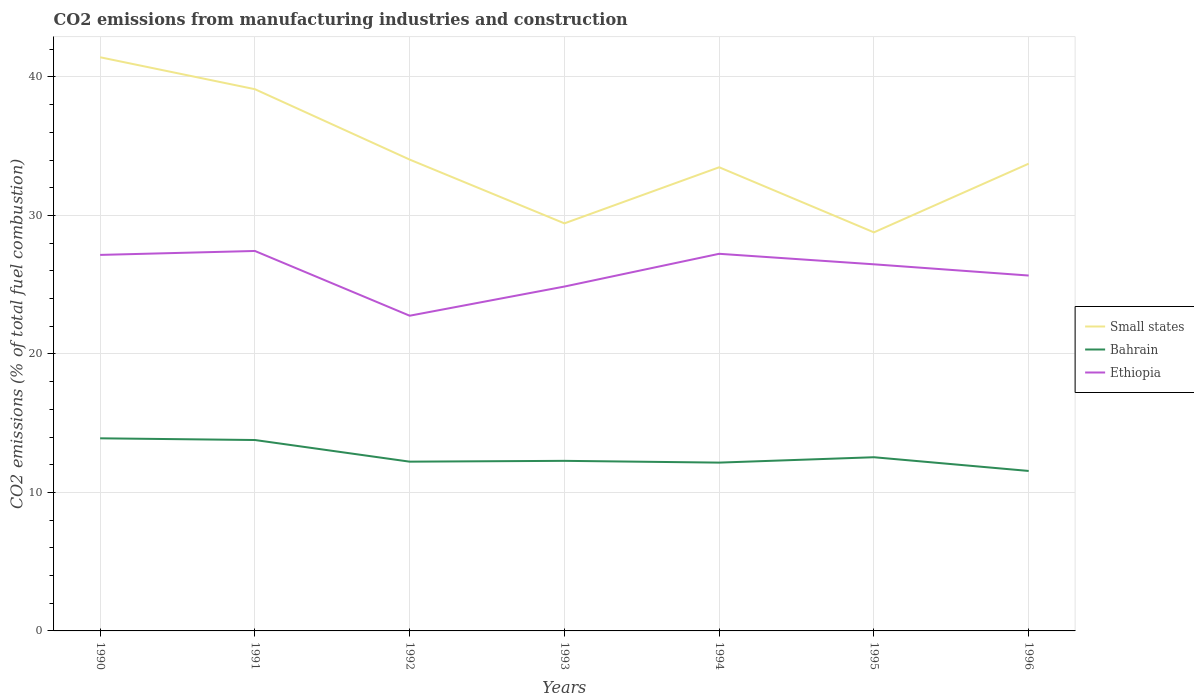Across all years, what is the maximum amount of CO2 emitted in Small states?
Ensure brevity in your answer.  28.78. What is the total amount of CO2 emitted in Bahrain in the graph?
Give a very brief answer. -0.39. What is the difference between the highest and the second highest amount of CO2 emitted in Small states?
Keep it short and to the point. 12.64. How many lines are there?
Your answer should be compact. 3. How many years are there in the graph?
Offer a very short reply. 7. Does the graph contain any zero values?
Provide a succinct answer. No. Does the graph contain grids?
Your answer should be compact. Yes. Where does the legend appear in the graph?
Your response must be concise. Center right. How are the legend labels stacked?
Provide a succinct answer. Vertical. What is the title of the graph?
Ensure brevity in your answer.  CO2 emissions from manufacturing industries and construction. Does "Spain" appear as one of the legend labels in the graph?
Offer a very short reply. No. What is the label or title of the Y-axis?
Keep it short and to the point. CO2 emissions (% of total fuel combustion). What is the CO2 emissions (% of total fuel combustion) of Small states in 1990?
Provide a succinct answer. 41.42. What is the CO2 emissions (% of total fuel combustion) in Bahrain in 1990?
Your answer should be compact. 13.91. What is the CO2 emissions (% of total fuel combustion) in Ethiopia in 1990?
Provide a short and direct response. 27.15. What is the CO2 emissions (% of total fuel combustion) of Small states in 1991?
Your answer should be compact. 39.11. What is the CO2 emissions (% of total fuel combustion) of Bahrain in 1991?
Offer a terse response. 13.78. What is the CO2 emissions (% of total fuel combustion) of Ethiopia in 1991?
Your response must be concise. 27.43. What is the CO2 emissions (% of total fuel combustion) of Small states in 1992?
Your response must be concise. 34.03. What is the CO2 emissions (% of total fuel combustion) in Bahrain in 1992?
Your answer should be very brief. 12.22. What is the CO2 emissions (% of total fuel combustion) of Ethiopia in 1992?
Provide a short and direct response. 22.76. What is the CO2 emissions (% of total fuel combustion) of Small states in 1993?
Keep it short and to the point. 29.43. What is the CO2 emissions (% of total fuel combustion) in Bahrain in 1993?
Ensure brevity in your answer.  12.28. What is the CO2 emissions (% of total fuel combustion) in Ethiopia in 1993?
Your answer should be compact. 24.86. What is the CO2 emissions (% of total fuel combustion) in Small states in 1994?
Make the answer very short. 33.48. What is the CO2 emissions (% of total fuel combustion) of Bahrain in 1994?
Provide a short and direct response. 12.15. What is the CO2 emissions (% of total fuel combustion) of Ethiopia in 1994?
Offer a very short reply. 27.23. What is the CO2 emissions (% of total fuel combustion) in Small states in 1995?
Your response must be concise. 28.78. What is the CO2 emissions (% of total fuel combustion) of Bahrain in 1995?
Offer a terse response. 12.54. What is the CO2 emissions (% of total fuel combustion) of Ethiopia in 1995?
Your answer should be compact. 26.47. What is the CO2 emissions (% of total fuel combustion) of Small states in 1996?
Provide a succinct answer. 33.74. What is the CO2 emissions (% of total fuel combustion) of Bahrain in 1996?
Your answer should be very brief. 11.55. What is the CO2 emissions (% of total fuel combustion) of Ethiopia in 1996?
Provide a succinct answer. 25.66. Across all years, what is the maximum CO2 emissions (% of total fuel combustion) in Small states?
Provide a short and direct response. 41.42. Across all years, what is the maximum CO2 emissions (% of total fuel combustion) in Bahrain?
Make the answer very short. 13.91. Across all years, what is the maximum CO2 emissions (% of total fuel combustion) in Ethiopia?
Ensure brevity in your answer.  27.43. Across all years, what is the minimum CO2 emissions (% of total fuel combustion) in Small states?
Give a very brief answer. 28.78. Across all years, what is the minimum CO2 emissions (% of total fuel combustion) of Bahrain?
Offer a very short reply. 11.55. Across all years, what is the minimum CO2 emissions (% of total fuel combustion) of Ethiopia?
Your answer should be compact. 22.76. What is the total CO2 emissions (% of total fuel combustion) in Small states in the graph?
Provide a succinct answer. 239.99. What is the total CO2 emissions (% of total fuel combustion) of Bahrain in the graph?
Your answer should be compact. 88.44. What is the total CO2 emissions (% of total fuel combustion) in Ethiopia in the graph?
Your response must be concise. 181.57. What is the difference between the CO2 emissions (% of total fuel combustion) in Small states in 1990 and that in 1991?
Your response must be concise. 2.31. What is the difference between the CO2 emissions (% of total fuel combustion) of Bahrain in 1990 and that in 1991?
Ensure brevity in your answer.  0.12. What is the difference between the CO2 emissions (% of total fuel combustion) of Ethiopia in 1990 and that in 1991?
Offer a very short reply. -0.28. What is the difference between the CO2 emissions (% of total fuel combustion) in Small states in 1990 and that in 1992?
Offer a terse response. 7.39. What is the difference between the CO2 emissions (% of total fuel combustion) of Bahrain in 1990 and that in 1992?
Provide a short and direct response. 1.69. What is the difference between the CO2 emissions (% of total fuel combustion) in Ethiopia in 1990 and that in 1992?
Ensure brevity in your answer.  4.39. What is the difference between the CO2 emissions (% of total fuel combustion) in Small states in 1990 and that in 1993?
Give a very brief answer. 11.99. What is the difference between the CO2 emissions (% of total fuel combustion) of Bahrain in 1990 and that in 1993?
Provide a succinct answer. 1.63. What is the difference between the CO2 emissions (% of total fuel combustion) in Ethiopia in 1990 and that in 1993?
Give a very brief answer. 2.28. What is the difference between the CO2 emissions (% of total fuel combustion) of Small states in 1990 and that in 1994?
Keep it short and to the point. 7.94. What is the difference between the CO2 emissions (% of total fuel combustion) of Bahrain in 1990 and that in 1994?
Make the answer very short. 1.75. What is the difference between the CO2 emissions (% of total fuel combustion) of Ethiopia in 1990 and that in 1994?
Your answer should be very brief. -0.08. What is the difference between the CO2 emissions (% of total fuel combustion) in Small states in 1990 and that in 1995?
Keep it short and to the point. 12.64. What is the difference between the CO2 emissions (% of total fuel combustion) in Bahrain in 1990 and that in 1995?
Your answer should be compact. 1.37. What is the difference between the CO2 emissions (% of total fuel combustion) of Ethiopia in 1990 and that in 1995?
Your answer should be very brief. 0.68. What is the difference between the CO2 emissions (% of total fuel combustion) in Small states in 1990 and that in 1996?
Make the answer very short. 7.68. What is the difference between the CO2 emissions (% of total fuel combustion) in Bahrain in 1990 and that in 1996?
Offer a terse response. 2.36. What is the difference between the CO2 emissions (% of total fuel combustion) of Ethiopia in 1990 and that in 1996?
Give a very brief answer. 1.49. What is the difference between the CO2 emissions (% of total fuel combustion) of Small states in 1991 and that in 1992?
Give a very brief answer. 5.08. What is the difference between the CO2 emissions (% of total fuel combustion) of Bahrain in 1991 and that in 1992?
Your response must be concise. 1.56. What is the difference between the CO2 emissions (% of total fuel combustion) of Ethiopia in 1991 and that in 1992?
Your answer should be compact. 4.67. What is the difference between the CO2 emissions (% of total fuel combustion) of Small states in 1991 and that in 1993?
Your response must be concise. 9.69. What is the difference between the CO2 emissions (% of total fuel combustion) of Bahrain in 1991 and that in 1993?
Your answer should be very brief. 1.5. What is the difference between the CO2 emissions (% of total fuel combustion) of Ethiopia in 1991 and that in 1993?
Give a very brief answer. 2.57. What is the difference between the CO2 emissions (% of total fuel combustion) in Small states in 1991 and that in 1994?
Keep it short and to the point. 5.64. What is the difference between the CO2 emissions (% of total fuel combustion) of Bahrain in 1991 and that in 1994?
Offer a terse response. 1.63. What is the difference between the CO2 emissions (% of total fuel combustion) in Ethiopia in 1991 and that in 1994?
Offer a terse response. 0.2. What is the difference between the CO2 emissions (% of total fuel combustion) of Small states in 1991 and that in 1995?
Ensure brevity in your answer.  10.34. What is the difference between the CO2 emissions (% of total fuel combustion) in Bahrain in 1991 and that in 1995?
Your response must be concise. 1.24. What is the difference between the CO2 emissions (% of total fuel combustion) of Ethiopia in 1991 and that in 1995?
Offer a very short reply. 0.96. What is the difference between the CO2 emissions (% of total fuel combustion) of Small states in 1991 and that in 1996?
Make the answer very short. 5.38. What is the difference between the CO2 emissions (% of total fuel combustion) in Bahrain in 1991 and that in 1996?
Offer a terse response. 2.23. What is the difference between the CO2 emissions (% of total fuel combustion) in Ethiopia in 1991 and that in 1996?
Your answer should be compact. 1.77. What is the difference between the CO2 emissions (% of total fuel combustion) of Small states in 1992 and that in 1993?
Offer a very short reply. 4.61. What is the difference between the CO2 emissions (% of total fuel combustion) in Bahrain in 1992 and that in 1993?
Your answer should be very brief. -0.06. What is the difference between the CO2 emissions (% of total fuel combustion) in Ethiopia in 1992 and that in 1993?
Your answer should be compact. -2.11. What is the difference between the CO2 emissions (% of total fuel combustion) in Small states in 1992 and that in 1994?
Offer a terse response. 0.56. What is the difference between the CO2 emissions (% of total fuel combustion) of Bahrain in 1992 and that in 1994?
Keep it short and to the point. 0.07. What is the difference between the CO2 emissions (% of total fuel combustion) of Ethiopia in 1992 and that in 1994?
Ensure brevity in your answer.  -4.47. What is the difference between the CO2 emissions (% of total fuel combustion) of Small states in 1992 and that in 1995?
Your answer should be very brief. 5.26. What is the difference between the CO2 emissions (% of total fuel combustion) of Bahrain in 1992 and that in 1995?
Keep it short and to the point. -0.32. What is the difference between the CO2 emissions (% of total fuel combustion) of Ethiopia in 1992 and that in 1995?
Ensure brevity in your answer.  -3.71. What is the difference between the CO2 emissions (% of total fuel combustion) in Small states in 1992 and that in 1996?
Give a very brief answer. 0.29. What is the difference between the CO2 emissions (% of total fuel combustion) of Bahrain in 1992 and that in 1996?
Make the answer very short. 0.67. What is the difference between the CO2 emissions (% of total fuel combustion) of Ethiopia in 1992 and that in 1996?
Provide a short and direct response. -2.9. What is the difference between the CO2 emissions (% of total fuel combustion) in Small states in 1993 and that in 1994?
Give a very brief answer. -4.05. What is the difference between the CO2 emissions (% of total fuel combustion) of Bahrain in 1993 and that in 1994?
Your answer should be very brief. 0.13. What is the difference between the CO2 emissions (% of total fuel combustion) of Ethiopia in 1993 and that in 1994?
Give a very brief answer. -2.37. What is the difference between the CO2 emissions (% of total fuel combustion) of Small states in 1993 and that in 1995?
Offer a terse response. 0.65. What is the difference between the CO2 emissions (% of total fuel combustion) of Bahrain in 1993 and that in 1995?
Provide a succinct answer. -0.26. What is the difference between the CO2 emissions (% of total fuel combustion) in Ethiopia in 1993 and that in 1995?
Offer a terse response. -1.61. What is the difference between the CO2 emissions (% of total fuel combustion) in Small states in 1993 and that in 1996?
Your answer should be compact. -4.31. What is the difference between the CO2 emissions (% of total fuel combustion) in Bahrain in 1993 and that in 1996?
Offer a terse response. 0.73. What is the difference between the CO2 emissions (% of total fuel combustion) in Ethiopia in 1993 and that in 1996?
Your response must be concise. -0.8. What is the difference between the CO2 emissions (% of total fuel combustion) in Small states in 1994 and that in 1995?
Keep it short and to the point. 4.7. What is the difference between the CO2 emissions (% of total fuel combustion) of Bahrain in 1994 and that in 1995?
Provide a succinct answer. -0.39. What is the difference between the CO2 emissions (% of total fuel combustion) in Ethiopia in 1994 and that in 1995?
Your answer should be very brief. 0.76. What is the difference between the CO2 emissions (% of total fuel combustion) of Small states in 1994 and that in 1996?
Your response must be concise. -0.26. What is the difference between the CO2 emissions (% of total fuel combustion) of Bahrain in 1994 and that in 1996?
Your answer should be very brief. 0.6. What is the difference between the CO2 emissions (% of total fuel combustion) of Ethiopia in 1994 and that in 1996?
Provide a succinct answer. 1.57. What is the difference between the CO2 emissions (% of total fuel combustion) of Small states in 1995 and that in 1996?
Your answer should be very brief. -4.96. What is the difference between the CO2 emissions (% of total fuel combustion) of Ethiopia in 1995 and that in 1996?
Ensure brevity in your answer.  0.81. What is the difference between the CO2 emissions (% of total fuel combustion) of Small states in 1990 and the CO2 emissions (% of total fuel combustion) of Bahrain in 1991?
Make the answer very short. 27.64. What is the difference between the CO2 emissions (% of total fuel combustion) in Small states in 1990 and the CO2 emissions (% of total fuel combustion) in Ethiopia in 1991?
Make the answer very short. 13.99. What is the difference between the CO2 emissions (% of total fuel combustion) in Bahrain in 1990 and the CO2 emissions (% of total fuel combustion) in Ethiopia in 1991?
Give a very brief answer. -13.53. What is the difference between the CO2 emissions (% of total fuel combustion) in Small states in 1990 and the CO2 emissions (% of total fuel combustion) in Bahrain in 1992?
Keep it short and to the point. 29.2. What is the difference between the CO2 emissions (% of total fuel combustion) of Small states in 1990 and the CO2 emissions (% of total fuel combustion) of Ethiopia in 1992?
Offer a terse response. 18.66. What is the difference between the CO2 emissions (% of total fuel combustion) in Bahrain in 1990 and the CO2 emissions (% of total fuel combustion) in Ethiopia in 1992?
Give a very brief answer. -8.85. What is the difference between the CO2 emissions (% of total fuel combustion) in Small states in 1990 and the CO2 emissions (% of total fuel combustion) in Bahrain in 1993?
Your response must be concise. 29.14. What is the difference between the CO2 emissions (% of total fuel combustion) in Small states in 1990 and the CO2 emissions (% of total fuel combustion) in Ethiopia in 1993?
Your response must be concise. 16.56. What is the difference between the CO2 emissions (% of total fuel combustion) of Bahrain in 1990 and the CO2 emissions (% of total fuel combustion) of Ethiopia in 1993?
Offer a very short reply. -10.96. What is the difference between the CO2 emissions (% of total fuel combustion) in Small states in 1990 and the CO2 emissions (% of total fuel combustion) in Bahrain in 1994?
Offer a terse response. 29.27. What is the difference between the CO2 emissions (% of total fuel combustion) in Small states in 1990 and the CO2 emissions (% of total fuel combustion) in Ethiopia in 1994?
Your answer should be compact. 14.19. What is the difference between the CO2 emissions (% of total fuel combustion) of Bahrain in 1990 and the CO2 emissions (% of total fuel combustion) of Ethiopia in 1994?
Offer a very short reply. -13.32. What is the difference between the CO2 emissions (% of total fuel combustion) of Small states in 1990 and the CO2 emissions (% of total fuel combustion) of Bahrain in 1995?
Provide a succinct answer. 28.88. What is the difference between the CO2 emissions (% of total fuel combustion) in Small states in 1990 and the CO2 emissions (% of total fuel combustion) in Ethiopia in 1995?
Provide a short and direct response. 14.95. What is the difference between the CO2 emissions (% of total fuel combustion) in Bahrain in 1990 and the CO2 emissions (% of total fuel combustion) in Ethiopia in 1995?
Provide a succinct answer. -12.56. What is the difference between the CO2 emissions (% of total fuel combustion) in Small states in 1990 and the CO2 emissions (% of total fuel combustion) in Bahrain in 1996?
Your answer should be compact. 29.87. What is the difference between the CO2 emissions (% of total fuel combustion) in Small states in 1990 and the CO2 emissions (% of total fuel combustion) in Ethiopia in 1996?
Your answer should be very brief. 15.76. What is the difference between the CO2 emissions (% of total fuel combustion) of Bahrain in 1990 and the CO2 emissions (% of total fuel combustion) of Ethiopia in 1996?
Offer a terse response. -11.75. What is the difference between the CO2 emissions (% of total fuel combustion) in Small states in 1991 and the CO2 emissions (% of total fuel combustion) in Bahrain in 1992?
Ensure brevity in your answer.  26.89. What is the difference between the CO2 emissions (% of total fuel combustion) in Small states in 1991 and the CO2 emissions (% of total fuel combustion) in Ethiopia in 1992?
Keep it short and to the point. 16.36. What is the difference between the CO2 emissions (% of total fuel combustion) in Bahrain in 1991 and the CO2 emissions (% of total fuel combustion) in Ethiopia in 1992?
Your answer should be compact. -8.97. What is the difference between the CO2 emissions (% of total fuel combustion) in Small states in 1991 and the CO2 emissions (% of total fuel combustion) in Bahrain in 1993?
Your answer should be very brief. 26.83. What is the difference between the CO2 emissions (% of total fuel combustion) in Small states in 1991 and the CO2 emissions (% of total fuel combustion) in Ethiopia in 1993?
Offer a very short reply. 14.25. What is the difference between the CO2 emissions (% of total fuel combustion) in Bahrain in 1991 and the CO2 emissions (% of total fuel combustion) in Ethiopia in 1993?
Your response must be concise. -11.08. What is the difference between the CO2 emissions (% of total fuel combustion) in Small states in 1991 and the CO2 emissions (% of total fuel combustion) in Bahrain in 1994?
Make the answer very short. 26.96. What is the difference between the CO2 emissions (% of total fuel combustion) in Small states in 1991 and the CO2 emissions (% of total fuel combustion) in Ethiopia in 1994?
Your response must be concise. 11.88. What is the difference between the CO2 emissions (% of total fuel combustion) in Bahrain in 1991 and the CO2 emissions (% of total fuel combustion) in Ethiopia in 1994?
Provide a succinct answer. -13.45. What is the difference between the CO2 emissions (% of total fuel combustion) in Small states in 1991 and the CO2 emissions (% of total fuel combustion) in Bahrain in 1995?
Keep it short and to the point. 26.57. What is the difference between the CO2 emissions (% of total fuel combustion) of Small states in 1991 and the CO2 emissions (% of total fuel combustion) of Ethiopia in 1995?
Offer a very short reply. 12.64. What is the difference between the CO2 emissions (% of total fuel combustion) of Bahrain in 1991 and the CO2 emissions (% of total fuel combustion) of Ethiopia in 1995?
Your answer should be compact. -12.69. What is the difference between the CO2 emissions (% of total fuel combustion) in Small states in 1991 and the CO2 emissions (% of total fuel combustion) in Bahrain in 1996?
Your answer should be compact. 27.56. What is the difference between the CO2 emissions (% of total fuel combustion) of Small states in 1991 and the CO2 emissions (% of total fuel combustion) of Ethiopia in 1996?
Give a very brief answer. 13.45. What is the difference between the CO2 emissions (% of total fuel combustion) in Bahrain in 1991 and the CO2 emissions (% of total fuel combustion) in Ethiopia in 1996?
Make the answer very short. -11.88. What is the difference between the CO2 emissions (% of total fuel combustion) of Small states in 1992 and the CO2 emissions (% of total fuel combustion) of Bahrain in 1993?
Your response must be concise. 21.75. What is the difference between the CO2 emissions (% of total fuel combustion) in Small states in 1992 and the CO2 emissions (% of total fuel combustion) in Ethiopia in 1993?
Provide a short and direct response. 9.17. What is the difference between the CO2 emissions (% of total fuel combustion) in Bahrain in 1992 and the CO2 emissions (% of total fuel combustion) in Ethiopia in 1993?
Your answer should be compact. -12.64. What is the difference between the CO2 emissions (% of total fuel combustion) in Small states in 1992 and the CO2 emissions (% of total fuel combustion) in Bahrain in 1994?
Your answer should be very brief. 21.88. What is the difference between the CO2 emissions (% of total fuel combustion) in Small states in 1992 and the CO2 emissions (% of total fuel combustion) in Ethiopia in 1994?
Give a very brief answer. 6.8. What is the difference between the CO2 emissions (% of total fuel combustion) in Bahrain in 1992 and the CO2 emissions (% of total fuel combustion) in Ethiopia in 1994?
Make the answer very short. -15.01. What is the difference between the CO2 emissions (% of total fuel combustion) in Small states in 1992 and the CO2 emissions (% of total fuel combustion) in Bahrain in 1995?
Ensure brevity in your answer.  21.49. What is the difference between the CO2 emissions (% of total fuel combustion) of Small states in 1992 and the CO2 emissions (% of total fuel combustion) of Ethiopia in 1995?
Ensure brevity in your answer.  7.56. What is the difference between the CO2 emissions (% of total fuel combustion) of Bahrain in 1992 and the CO2 emissions (% of total fuel combustion) of Ethiopia in 1995?
Provide a succinct answer. -14.25. What is the difference between the CO2 emissions (% of total fuel combustion) of Small states in 1992 and the CO2 emissions (% of total fuel combustion) of Bahrain in 1996?
Your answer should be compact. 22.48. What is the difference between the CO2 emissions (% of total fuel combustion) in Small states in 1992 and the CO2 emissions (% of total fuel combustion) in Ethiopia in 1996?
Offer a terse response. 8.37. What is the difference between the CO2 emissions (% of total fuel combustion) of Bahrain in 1992 and the CO2 emissions (% of total fuel combustion) of Ethiopia in 1996?
Your answer should be very brief. -13.44. What is the difference between the CO2 emissions (% of total fuel combustion) in Small states in 1993 and the CO2 emissions (% of total fuel combustion) in Bahrain in 1994?
Offer a very short reply. 17.27. What is the difference between the CO2 emissions (% of total fuel combustion) of Small states in 1993 and the CO2 emissions (% of total fuel combustion) of Ethiopia in 1994?
Make the answer very short. 2.2. What is the difference between the CO2 emissions (% of total fuel combustion) of Bahrain in 1993 and the CO2 emissions (% of total fuel combustion) of Ethiopia in 1994?
Make the answer very short. -14.95. What is the difference between the CO2 emissions (% of total fuel combustion) of Small states in 1993 and the CO2 emissions (% of total fuel combustion) of Bahrain in 1995?
Give a very brief answer. 16.89. What is the difference between the CO2 emissions (% of total fuel combustion) in Small states in 1993 and the CO2 emissions (% of total fuel combustion) in Ethiopia in 1995?
Your response must be concise. 2.96. What is the difference between the CO2 emissions (% of total fuel combustion) of Bahrain in 1993 and the CO2 emissions (% of total fuel combustion) of Ethiopia in 1995?
Ensure brevity in your answer.  -14.19. What is the difference between the CO2 emissions (% of total fuel combustion) of Small states in 1993 and the CO2 emissions (% of total fuel combustion) of Bahrain in 1996?
Give a very brief answer. 17.88. What is the difference between the CO2 emissions (% of total fuel combustion) of Small states in 1993 and the CO2 emissions (% of total fuel combustion) of Ethiopia in 1996?
Make the answer very short. 3.77. What is the difference between the CO2 emissions (% of total fuel combustion) of Bahrain in 1993 and the CO2 emissions (% of total fuel combustion) of Ethiopia in 1996?
Offer a very short reply. -13.38. What is the difference between the CO2 emissions (% of total fuel combustion) of Small states in 1994 and the CO2 emissions (% of total fuel combustion) of Bahrain in 1995?
Keep it short and to the point. 20.94. What is the difference between the CO2 emissions (% of total fuel combustion) of Small states in 1994 and the CO2 emissions (% of total fuel combustion) of Ethiopia in 1995?
Your answer should be very brief. 7.01. What is the difference between the CO2 emissions (% of total fuel combustion) of Bahrain in 1994 and the CO2 emissions (% of total fuel combustion) of Ethiopia in 1995?
Your answer should be compact. -14.32. What is the difference between the CO2 emissions (% of total fuel combustion) of Small states in 1994 and the CO2 emissions (% of total fuel combustion) of Bahrain in 1996?
Your answer should be very brief. 21.93. What is the difference between the CO2 emissions (% of total fuel combustion) of Small states in 1994 and the CO2 emissions (% of total fuel combustion) of Ethiopia in 1996?
Your response must be concise. 7.82. What is the difference between the CO2 emissions (% of total fuel combustion) in Bahrain in 1994 and the CO2 emissions (% of total fuel combustion) in Ethiopia in 1996?
Give a very brief answer. -13.51. What is the difference between the CO2 emissions (% of total fuel combustion) of Small states in 1995 and the CO2 emissions (% of total fuel combustion) of Bahrain in 1996?
Offer a terse response. 17.23. What is the difference between the CO2 emissions (% of total fuel combustion) of Small states in 1995 and the CO2 emissions (% of total fuel combustion) of Ethiopia in 1996?
Make the answer very short. 3.12. What is the difference between the CO2 emissions (% of total fuel combustion) of Bahrain in 1995 and the CO2 emissions (% of total fuel combustion) of Ethiopia in 1996?
Offer a very short reply. -13.12. What is the average CO2 emissions (% of total fuel combustion) of Small states per year?
Keep it short and to the point. 34.28. What is the average CO2 emissions (% of total fuel combustion) in Bahrain per year?
Your answer should be compact. 12.63. What is the average CO2 emissions (% of total fuel combustion) of Ethiopia per year?
Make the answer very short. 25.94. In the year 1990, what is the difference between the CO2 emissions (% of total fuel combustion) in Small states and CO2 emissions (% of total fuel combustion) in Bahrain?
Offer a terse response. 27.51. In the year 1990, what is the difference between the CO2 emissions (% of total fuel combustion) in Small states and CO2 emissions (% of total fuel combustion) in Ethiopia?
Provide a succinct answer. 14.27. In the year 1990, what is the difference between the CO2 emissions (% of total fuel combustion) in Bahrain and CO2 emissions (% of total fuel combustion) in Ethiopia?
Make the answer very short. -13.24. In the year 1991, what is the difference between the CO2 emissions (% of total fuel combustion) of Small states and CO2 emissions (% of total fuel combustion) of Bahrain?
Provide a short and direct response. 25.33. In the year 1991, what is the difference between the CO2 emissions (% of total fuel combustion) in Small states and CO2 emissions (% of total fuel combustion) in Ethiopia?
Your answer should be compact. 11.68. In the year 1991, what is the difference between the CO2 emissions (% of total fuel combustion) in Bahrain and CO2 emissions (% of total fuel combustion) in Ethiopia?
Give a very brief answer. -13.65. In the year 1992, what is the difference between the CO2 emissions (% of total fuel combustion) in Small states and CO2 emissions (% of total fuel combustion) in Bahrain?
Keep it short and to the point. 21.81. In the year 1992, what is the difference between the CO2 emissions (% of total fuel combustion) of Small states and CO2 emissions (% of total fuel combustion) of Ethiopia?
Provide a succinct answer. 11.27. In the year 1992, what is the difference between the CO2 emissions (% of total fuel combustion) of Bahrain and CO2 emissions (% of total fuel combustion) of Ethiopia?
Offer a terse response. -10.54. In the year 1993, what is the difference between the CO2 emissions (% of total fuel combustion) in Small states and CO2 emissions (% of total fuel combustion) in Bahrain?
Keep it short and to the point. 17.15. In the year 1993, what is the difference between the CO2 emissions (% of total fuel combustion) of Small states and CO2 emissions (% of total fuel combustion) of Ethiopia?
Your answer should be very brief. 4.56. In the year 1993, what is the difference between the CO2 emissions (% of total fuel combustion) of Bahrain and CO2 emissions (% of total fuel combustion) of Ethiopia?
Provide a short and direct response. -12.58. In the year 1994, what is the difference between the CO2 emissions (% of total fuel combustion) in Small states and CO2 emissions (% of total fuel combustion) in Bahrain?
Offer a terse response. 21.32. In the year 1994, what is the difference between the CO2 emissions (% of total fuel combustion) of Small states and CO2 emissions (% of total fuel combustion) of Ethiopia?
Provide a short and direct response. 6.25. In the year 1994, what is the difference between the CO2 emissions (% of total fuel combustion) of Bahrain and CO2 emissions (% of total fuel combustion) of Ethiopia?
Offer a terse response. -15.08. In the year 1995, what is the difference between the CO2 emissions (% of total fuel combustion) of Small states and CO2 emissions (% of total fuel combustion) of Bahrain?
Give a very brief answer. 16.24. In the year 1995, what is the difference between the CO2 emissions (% of total fuel combustion) in Small states and CO2 emissions (% of total fuel combustion) in Ethiopia?
Your answer should be very brief. 2.31. In the year 1995, what is the difference between the CO2 emissions (% of total fuel combustion) of Bahrain and CO2 emissions (% of total fuel combustion) of Ethiopia?
Your answer should be very brief. -13.93. In the year 1996, what is the difference between the CO2 emissions (% of total fuel combustion) of Small states and CO2 emissions (% of total fuel combustion) of Bahrain?
Your response must be concise. 22.19. In the year 1996, what is the difference between the CO2 emissions (% of total fuel combustion) in Small states and CO2 emissions (% of total fuel combustion) in Ethiopia?
Make the answer very short. 8.08. In the year 1996, what is the difference between the CO2 emissions (% of total fuel combustion) of Bahrain and CO2 emissions (% of total fuel combustion) of Ethiopia?
Your answer should be compact. -14.11. What is the ratio of the CO2 emissions (% of total fuel combustion) in Small states in 1990 to that in 1991?
Your response must be concise. 1.06. What is the ratio of the CO2 emissions (% of total fuel combustion) of Bahrain in 1990 to that in 1991?
Your answer should be very brief. 1.01. What is the ratio of the CO2 emissions (% of total fuel combustion) in Ethiopia in 1990 to that in 1991?
Keep it short and to the point. 0.99. What is the ratio of the CO2 emissions (% of total fuel combustion) in Small states in 1990 to that in 1992?
Give a very brief answer. 1.22. What is the ratio of the CO2 emissions (% of total fuel combustion) in Bahrain in 1990 to that in 1992?
Give a very brief answer. 1.14. What is the ratio of the CO2 emissions (% of total fuel combustion) in Ethiopia in 1990 to that in 1992?
Provide a succinct answer. 1.19. What is the ratio of the CO2 emissions (% of total fuel combustion) in Small states in 1990 to that in 1993?
Your answer should be compact. 1.41. What is the ratio of the CO2 emissions (% of total fuel combustion) of Bahrain in 1990 to that in 1993?
Offer a terse response. 1.13. What is the ratio of the CO2 emissions (% of total fuel combustion) of Ethiopia in 1990 to that in 1993?
Keep it short and to the point. 1.09. What is the ratio of the CO2 emissions (% of total fuel combustion) in Small states in 1990 to that in 1994?
Your answer should be compact. 1.24. What is the ratio of the CO2 emissions (% of total fuel combustion) of Bahrain in 1990 to that in 1994?
Offer a very short reply. 1.14. What is the ratio of the CO2 emissions (% of total fuel combustion) of Small states in 1990 to that in 1995?
Offer a very short reply. 1.44. What is the ratio of the CO2 emissions (% of total fuel combustion) in Bahrain in 1990 to that in 1995?
Your answer should be compact. 1.11. What is the ratio of the CO2 emissions (% of total fuel combustion) in Ethiopia in 1990 to that in 1995?
Ensure brevity in your answer.  1.03. What is the ratio of the CO2 emissions (% of total fuel combustion) of Small states in 1990 to that in 1996?
Give a very brief answer. 1.23. What is the ratio of the CO2 emissions (% of total fuel combustion) of Bahrain in 1990 to that in 1996?
Provide a succinct answer. 1.2. What is the ratio of the CO2 emissions (% of total fuel combustion) in Ethiopia in 1990 to that in 1996?
Give a very brief answer. 1.06. What is the ratio of the CO2 emissions (% of total fuel combustion) in Small states in 1991 to that in 1992?
Ensure brevity in your answer.  1.15. What is the ratio of the CO2 emissions (% of total fuel combustion) in Bahrain in 1991 to that in 1992?
Your answer should be very brief. 1.13. What is the ratio of the CO2 emissions (% of total fuel combustion) in Ethiopia in 1991 to that in 1992?
Offer a very short reply. 1.21. What is the ratio of the CO2 emissions (% of total fuel combustion) of Small states in 1991 to that in 1993?
Give a very brief answer. 1.33. What is the ratio of the CO2 emissions (% of total fuel combustion) of Bahrain in 1991 to that in 1993?
Keep it short and to the point. 1.12. What is the ratio of the CO2 emissions (% of total fuel combustion) of Ethiopia in 1991 to that in 1993?
Keep it short and to the point. 1.1. What is the ratio of the CO2 emissions (% of total fuel combustion) in Small states in 1991 to that in 1994?
Provide a succinct answer. 1.17. What is the ratio of the CO2 emissions (% of total fuel combustion) of Bahrain in 1991 to that in 1994?
Provide a succinct answer. 1.13. What is the ratio of the CO2 emissions (% of total fuel combustion) of Ethiopia in 1991 to that in 1994?
Your answer should be very brief. 1.01. What is the ratio of the CO2 emissions (% of total fuel combustion) in Small states in 1991 to that in 1995?
Provide a succinct answer. 1.36. What is the ratio of the CO2 emissions (% of total fuel combustion) in Bahrain in 1991 to that in 1995?
Your response must be concise. 1.1. What is the ratio of the CO2 emissions (% of total fuel combustion) of Ethiopia in 1991 to that in 1995?
Offer a very short reply. 1.04. What is the ratio of the CO2 emissions (% of total fuel combustion) of Small states in 1991 to that in 1996?
Offer a very short reply. 1.16. What is the ratio of the CO2 emissions (% of total fuel combustion) in Bahrain in 1991 to that in 1996?
Your answer should be compact. 1.19. What is the ratio of the CO2 emissions (% of total fuel combustion) in Ethiopia in 1991 to that in 1996?
Your answer should be very brief. 1.07. What is the ratio of the CO2 emissions (% of total fuel combustion) in Small states in 1992 to that in 1993?
Your answer should be compact. 1.16. What is the ratio of the CO2 emissions (% of total fuel combustion) of Ethiopia in 1992 to that in 1993?
Provide a succinct answer. 0.92. What is the ratio of the CO2 emissions (% of total fuel combustion) in Small states in 1992 to that in 1994?
Your answer should be compact. 1.02. What is the ratio of the CO2 emissions (% of total fuel combustion) of Bahrain in 1992 to that in 1994?
Keep it short and to the point. 1.01. What is the ratio of the CO2 emissions (% of total fuel combustion) of Ethiopia in 1992 to that in 1994?
Your answer should be very brief. 0.84. What is the ratio of the CO2 emissions (% of total fuel combustion) in Small states in 1992 to that in 1995?
Give a very brief answer. 1.18. What is the ratio of the CO2 emissions (% of total fuel combustion) in Bahrain in 1992 to that in 1995?
Your answer should be very brief. 0.97. What is the ratio of the CO2 emissions (% of total fuel combustion) of Ethiopia in 1992 to that in 1995?
Provide a succinct answer. 0.86. What is the ratio of the CO2 emissions (% of total fuel combustion) of Small states in 1992 to that in 1996?
Keep it short and to the point. 1.01. What is the ratio of the CO2 emissions (% of total fuel combustion) of Bahrain in 1992 to that in 1996?
Your answer should be very brief. 1.06. What is the ratio of the CO2 emissions (% of total fuel combustion) of Ethiopia in 1992 to that in 1996?
Offer a very short reply. 0.89. What is the ratio of the CO2 emissions (% of total fuel combustion) in Small states in 1993 to that in 1994?
Provide a short and direct response. 0.88. What is the ratio of the CO2 emissions (% of total fuel combustion) of Bahrain in 1993 to that in 1994?
Your response must be concise. 1.01. What is the ratio of the CO2 emissions (% of total fuel combustion) in Ethiopia in 1993 to that in 1994?
Ensure brevity in your answer.  0.91. What is the ratio of the CO2 emissions (% of total fuel combustion) of Small states in 1993 to that in 1995?
Offer a terse response. 1.02. What is the ratio of the CO2 emissions (% of total fuel combustion) of Bahrain in 1993 to that in 1995?
Offer a very short reply. 0.98. What is the ratio of the CO2 emissions (% of total fuel combustion) of Ethiopia in 1993 to that in 1995?
Give a very brief answer. 0.94. What is the ratio of the CO2 emissions (% of total fuel combustion) of Small states in 1993 to that in 1996?
Offer a very short reply. 0.87. What is the ratio of the CO2 emissions (% of total fuel combustion) in Bahrain in 1993 to that in 1996?
Your answer should be very brief. 1.06. What is the ratio of the CO2 emissions (% of total fuel combustion) in Small states in 1994 to that in 1995?
Your answer should be compact. 1.16. What is the ratio of the CO2 emissions (% of total fuel combustion) of Bahrain in 1994 to that in 1995?
Offer a terse response. 0.97. What is the ratio of the CO2 emissions (% of total fuel combustion) of Ethiopia in 1994 to that in 1995?
Your answer should be very brief. 1.03. What is the ratio of the CO2 emissions (% of total fuel combustion) in Small states in 1994 to that in 1996?
Your response must be concise. 0.99. What is the ratio of the CO2 emissions (% of total fuel combustion) in Bahrain in 1994 to that in 1996?
Provide a succinct answer. 1.05. What is the ratio of the CO2 emissions (% of total fuel combustion) of Ethiopia in 1994 to that in 1996?
Provide a short and direct response. 1.06. What is the ratio of the CO2 emissions (% of total fuel combustion) in Small states in 1995 to that in 1996?
Provide a short and direct response. 0.85. What is the ratio of the CO2 emissions (% of total fuel combustion) in Bahrain in 1995 to that in 1996?
Ensure brevity in your answer.  1.09. What is the ratio of the CO2 emissions (% of total fuel combustion) in Ethiopia in 1995 to that in 1996?
Provide a succinct answer. 1.03. What is the difference between the highest and the second highest CO2 emissions (% of total fuel combustion) in Small states?
Make the answer very short. 2.31. What is the difference between the highest and the second highest CO2 emissions (% of total fuel combustion) of Bahrain?
Make the answer very short. 0.12. What is the difference between the highest and the second highest CO2 emissions (% of total fuel combustion) in Ethiopia?
Keep it short and to the point. 0.2. What is the difference between the highest and the lowest CO2 emissions (% of total fuel combustion) of Small states?
Offer a terse response. 12.64. What is the difference between the highest and the lowest CO2 emissions (% of total fuel combustion) in Bahrain?
Offer a terse response. 2.36. What is the difference between the highest and the lowest CO2 emissions (% of total fuel combustion) in Ethiopia?
Offer a terse response. 4.67. 